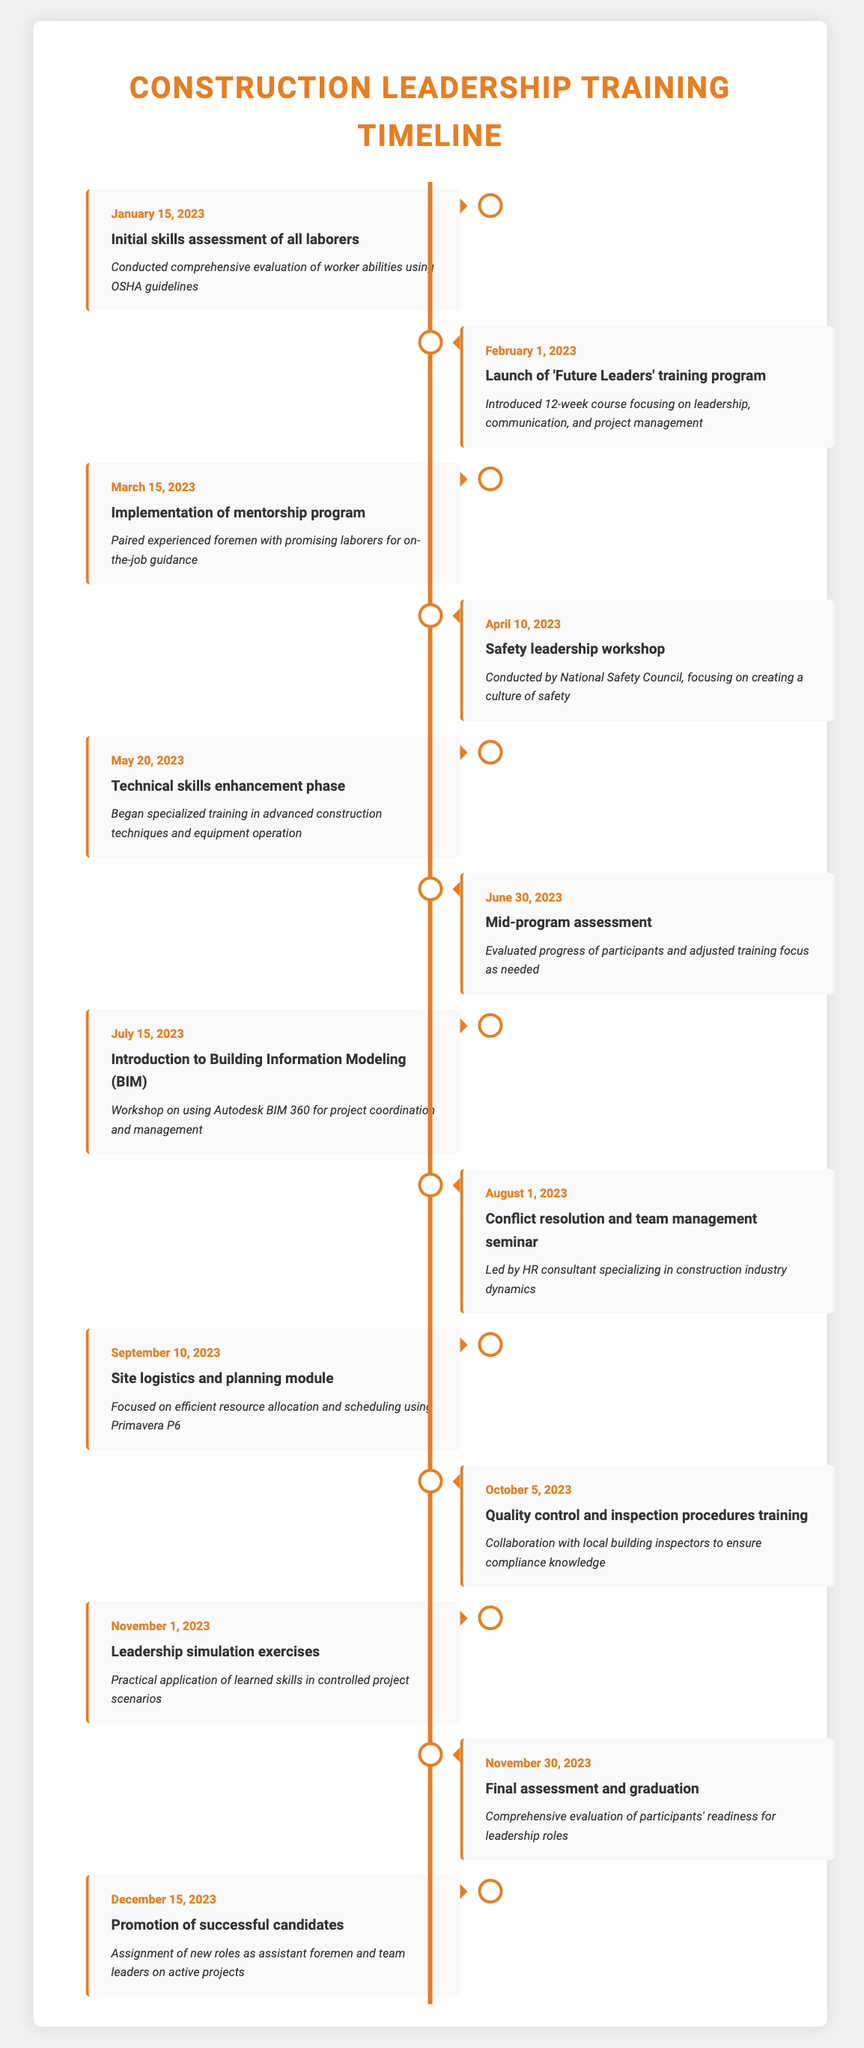What event occurred on March 15, 2023? The timeline shows that the event on March 15, 2023, is the implementation of the mentorship program. This is reported under the event column for that date.
Answer: Implementation of mentorship program What was the main focus of the 'Future Leaders' training program launched on February 1, 2023? The description for the event on February 1, 2023, indicates that the 'Future Leaders' training program focused on leadership, communication, and project management.
Answer: Leadership, communication, and project management How many weeks did the 'Future Leaders' training program last? The program was specifically defined as a 12-week course. This is directly stated in the description associated with the event on February 1, 2023.
Answer: 12 weeks Did the program include any workshops on safety leadership? Yes, there was a safety leadership workshop held on April 10, 2023, performed by the National Safety Council. This was clearly indicated in the event description.
Answer: Yes What was the event that provided practical applications of learned skills, and when did it occur? The leadership simulation exercises were designed for practical application and occurred on November 1, 2023. This can be verified by checking the relevant dates and descriptions in the table.
Answer: Leadership simulation exercises, November 1, 2023 What was the total time span from the initial skills assessment to the promotion of successful candidates? The initial skills assessment took place on January 15, 2023, and the promotion of successful candidates was on December 15, 2023. This spans from January to December, equating to 11 months.
Answer: 11 months During which month was the Site logistics and planning module conducted? As per the timeline, the site logistics and planning module was conducted on September 10, 2023, indicating that it was in September. This is found by locating the event date in the table.
Answer: September Was there a mid-program assessment, and when did it take place? Yes, there was a mid-program assessment, and it took place on June 30, 2023. The event is clearly listed in the timeline.
Answer: Yes, June 30, 2023 Identify the last event in the timeline and its associated description. The last event is the promotion of successful candidates, which will result in assigning new roles as assistant foremen and team leaders. This is confirmed by finding the last date and details in the table.
Answer: Promotion of successful candidates: Assignment of new roles as assistant foremen and team leaders on active projects 